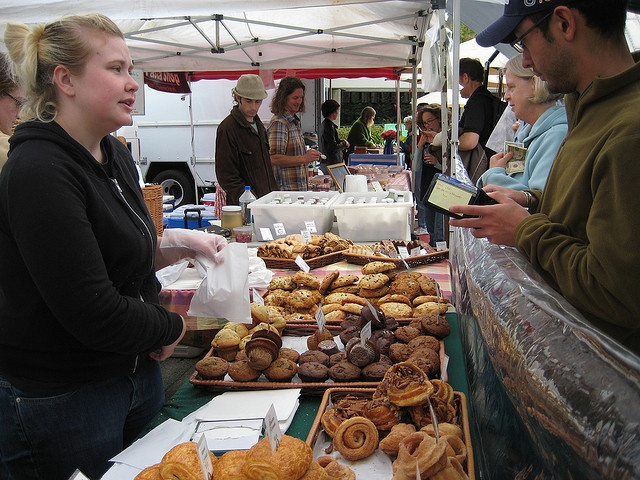Describe the objects in this image and their specific colors. I can see people in lightgray, black, gray, and darkgray tones, people in lightgray, black, maroon, gray, and brown tones, people in lightgray, black, gray, and darkgray tones, people in lightgray, darkgray, and gray tones, and people in lightgray, black, gray, maroon, and brown tones in this image. 